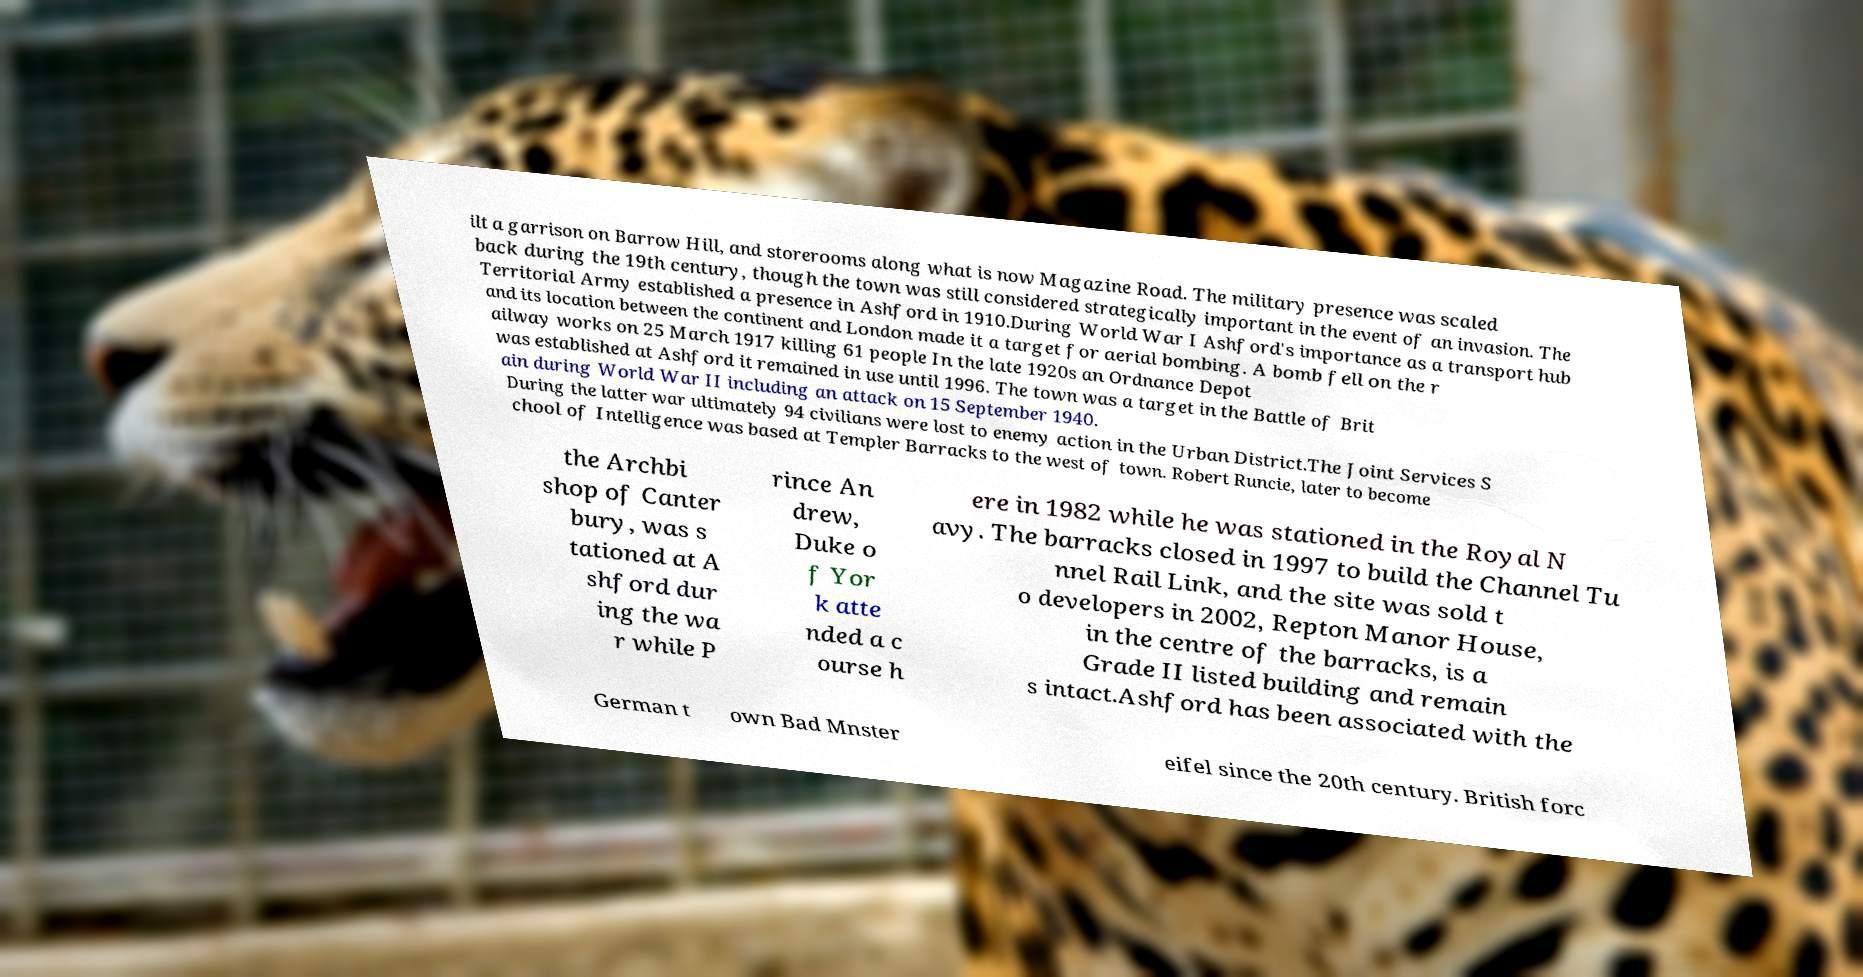For documentation purposes, I need the text within this image transcribed. Could you provide that? ilt a garrison on Barrow Hill, and storerooms along what is now Magazine Road. The military presence was scaled back during the 19th century, though the town was still considered strategically important in the event of an invasion. The Territorial Army established a presence in Ashford in 1910.During World War I Ashford's importance as a transport hub and its location between the continent and London made it a target for aerial bombing. A bomb fell on the r ailway works on 25 March 1917 killing 61 people In the late 1920s an Ordnance Depot was established at Ashford it remained in use until 1996. The town was a target in the Battle of Brit ain during World War II including an attack on 15 September 1940. During the latter war ultimately 94 civilians were lost to enemy action in the Urban District.The Joint Services S chool of Intelligence was based at Templer Barracks to the west of town. Robert Runcie, later to become the Archbi shop of Canter bury, was s tationed at A shford dur ing the wa r while P rince An drew, Duke o f Yor k atte nded a c ourse h ere in 1982 while he was stationed in the Royal N avy. The barracks closed in 1997 to build the Channel Tu nnel Rail Link, and the site was sold t o developers in 2002, Repton Manor House, in the centre of the barracks, is a Grade II listed building and remain s intact.Ashford has been associated with the German t own Bad Mnster eifel since the 20th century. British forc 